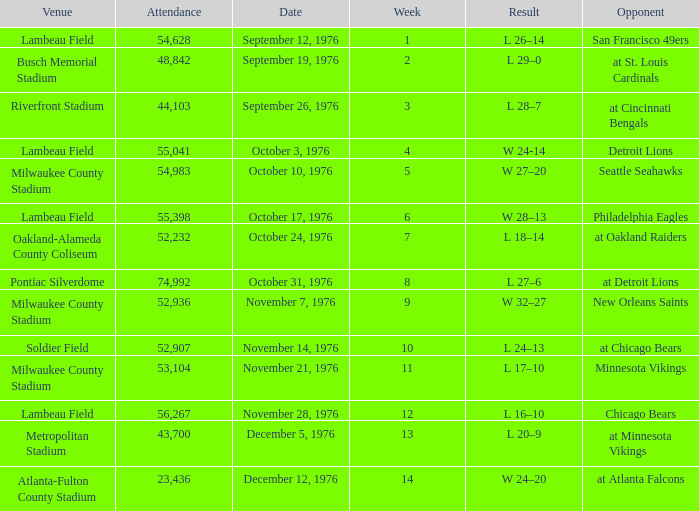What is the lowest week number where they played against the Detroit Lions? 4.0. 